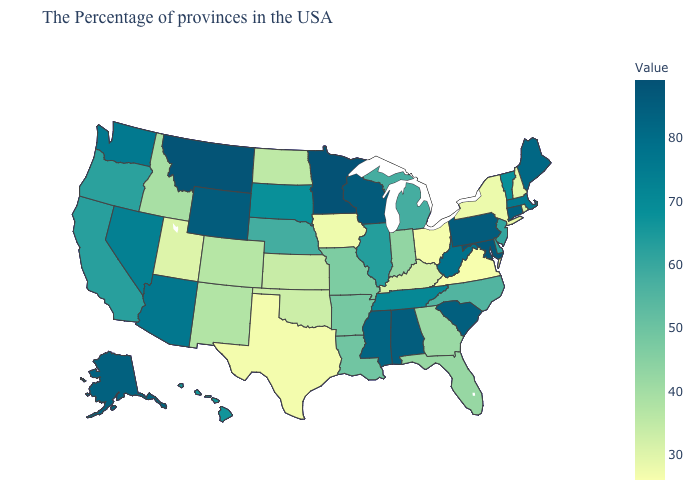Which states have the highest value in the USA?
Keep it brief. Minnesota. Among the states that border Illinois , which have the highest value?
Answer briefly. Wisconsin. Is the legend a continuous bar?
Keep it brief. Yes. Does Minnesota have the highest value in the USA?
Write a very short answer. Yes. Among the states that border Montana , which have the lowest value?
Be succinct. North Dakota. Does Maryland have a lower value than Vermont?
Be succinct. No. 